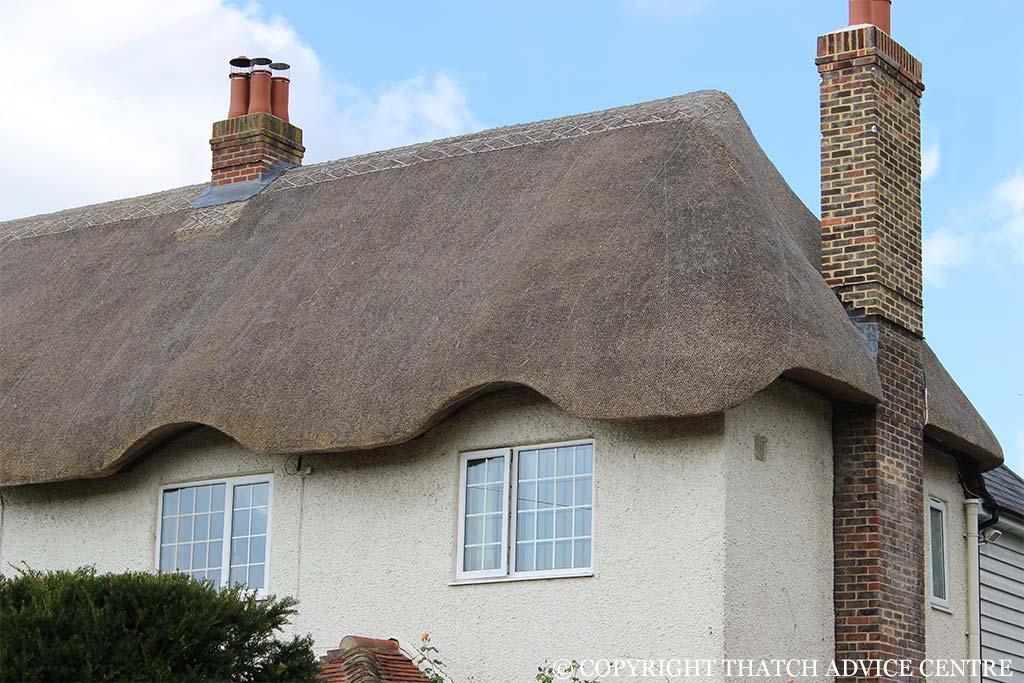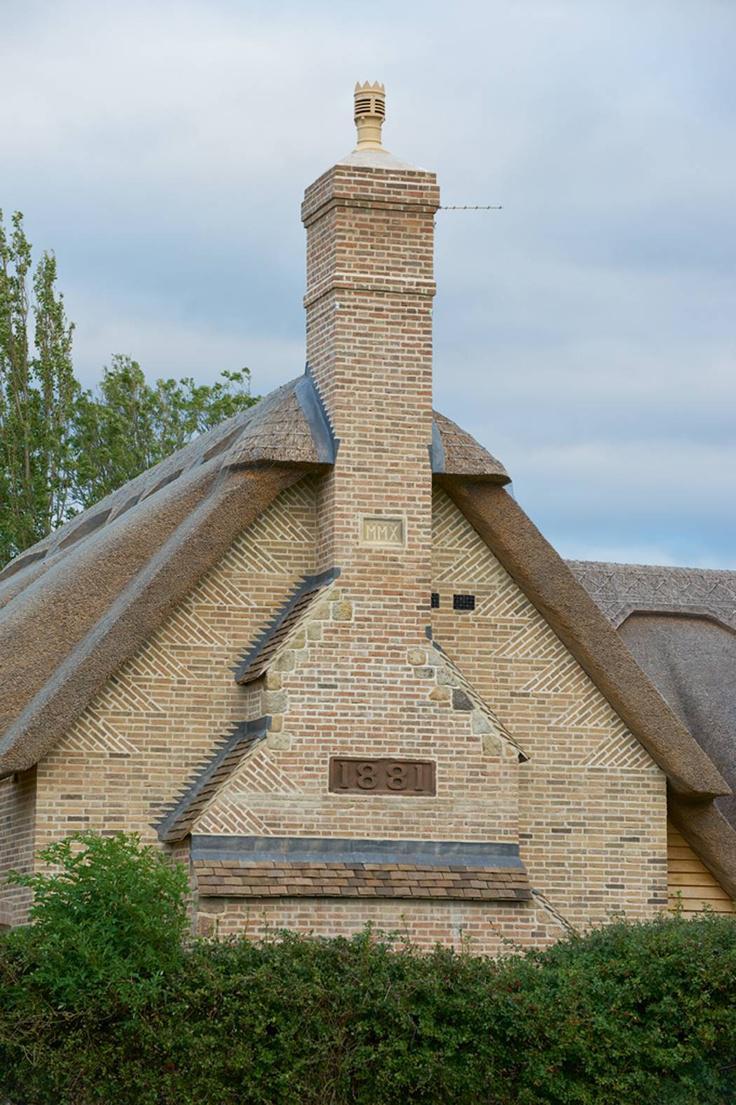The first image is the image on the left, the second image is the image on the right. For the images shown, is this caption "One of the houses has two chimneys." true? Answer yes or no. Yes. 